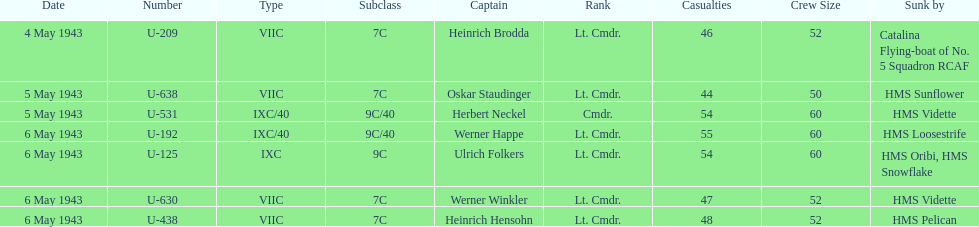What is the only vessel to sink multiple u-boats? HMS Vidette. 